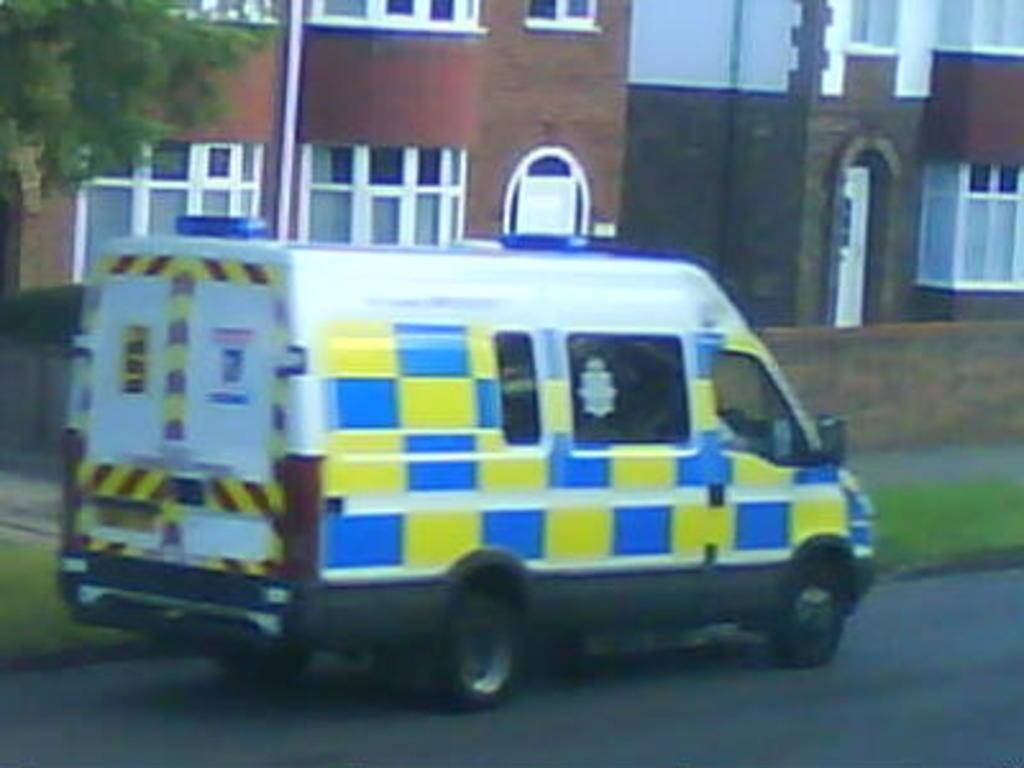Describe this image in one or two sentences. In this picture there is a van in the center of the image and there is grassland on the right and left side of the image, there are buildings in the background area of the image, there is a tree in the top left side of the image. 